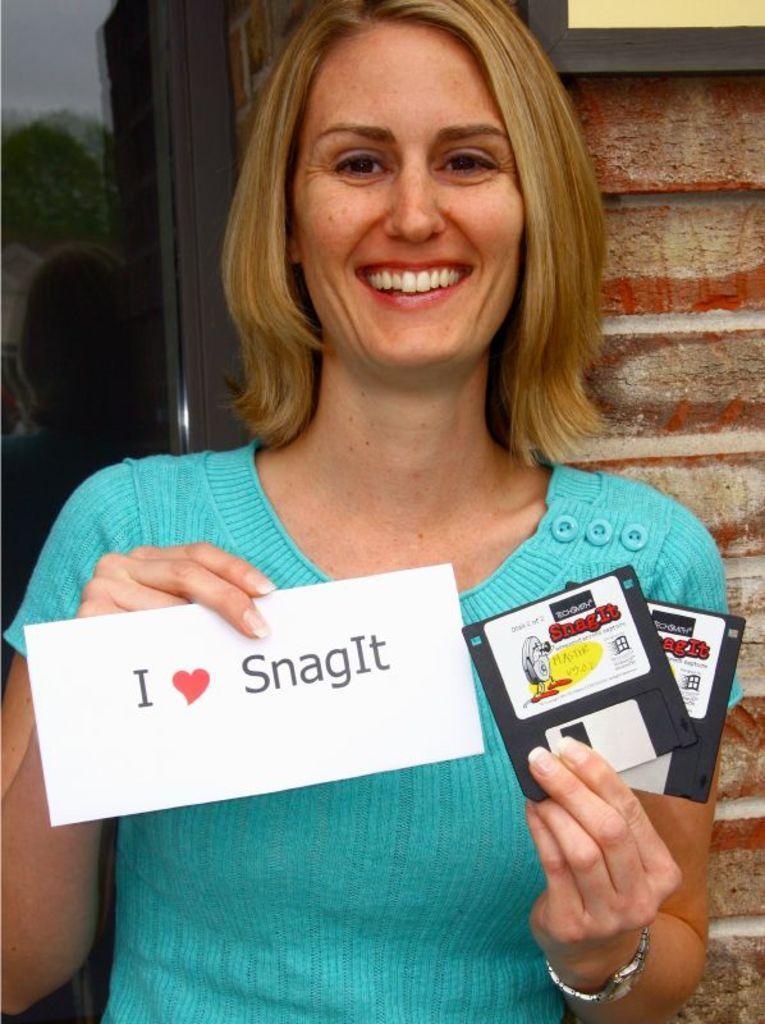Please provide a concise description of this image. In this picture we can see a woman holding cards with her hands and standing and smiling and in the background we can see a frame on the wall. 